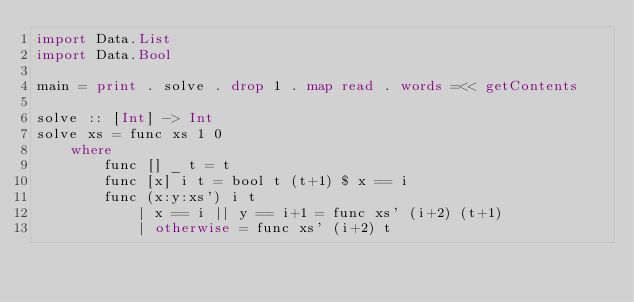Convert code to text. <code><loc_0><loc_0><loc_500><loc_500><_Haskell_>import Data.List
import Data.Bool

main = print . solve . drop 1 . map read . words =<< getContents

solve :: [Int] -> Int
solve xs = func xs 1 0
    where
        func [] _ t = t
        func [x] i t = bool t (t+1) $ x == i
        func (x:y:xs') i t
            | x == i || y == i+1 = func xs' (i+2) (t+1)
            | otherwise = func xs' (i+2) t
</code> 